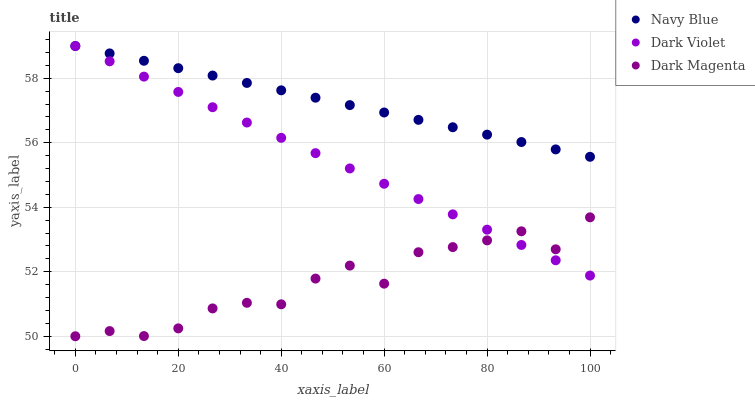Does Dark Magenta have the minimum area under the curve?
Answer yes or no. Yes. Does Navy Blue have the maximum area under the curve?
Answer yes or no. Yes. Does Dark Violet have the minimum area under the curve?
Answer yes or no. No. Does Dark Violet have the maximum area under the curve?
Answer yes or no. No. Is Navy Blue the smoothest?
Answer yes or no. Yes. Is Dark Magenta the roughest?
Answer yes or no. Yes. Is Dark Violet the smoothest?
Answer yes or no. No. Is Dark Violet the roughest?
Answer yes or no. No. Does Dark Magenta have the lowest value?
Answer yes or no. Yes. Does Dark Violet have the lowest value?
Answer yes or no. No. Does Dark Violet have the highest value?
Answer yes or no. Yes. Does Dark Magenta have the highest value?
Answer yes or no. No. Is Dark Magenta less than Navy Blue?
Answer yes or no. Yes. Is Navy Blue greater than Dark Magenta?
Answer yes or no. Yes. Does Dark Violet intersect Dark Magenta?
Answer yes or no. Yes. Is Dark Violet less than Dark Magenta?
Answer yes or no. No. Is Dark Violet greater than Dark Magenta?
Answer yes or no. No. Does Dark Magenta intersect Navy Blue?
Answer yes or no. No. 